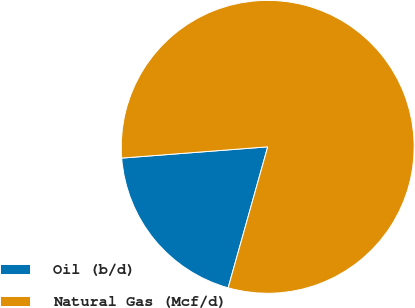Convert chart. <chart><loc_0><loc_0><loc_500><loc_500><pie_chart><fcel>Oil (b/d)<fcel>Natural Gas (Mcf/d)<nl><fcel>19.42%<fcel>80.58%<nl></chart> 